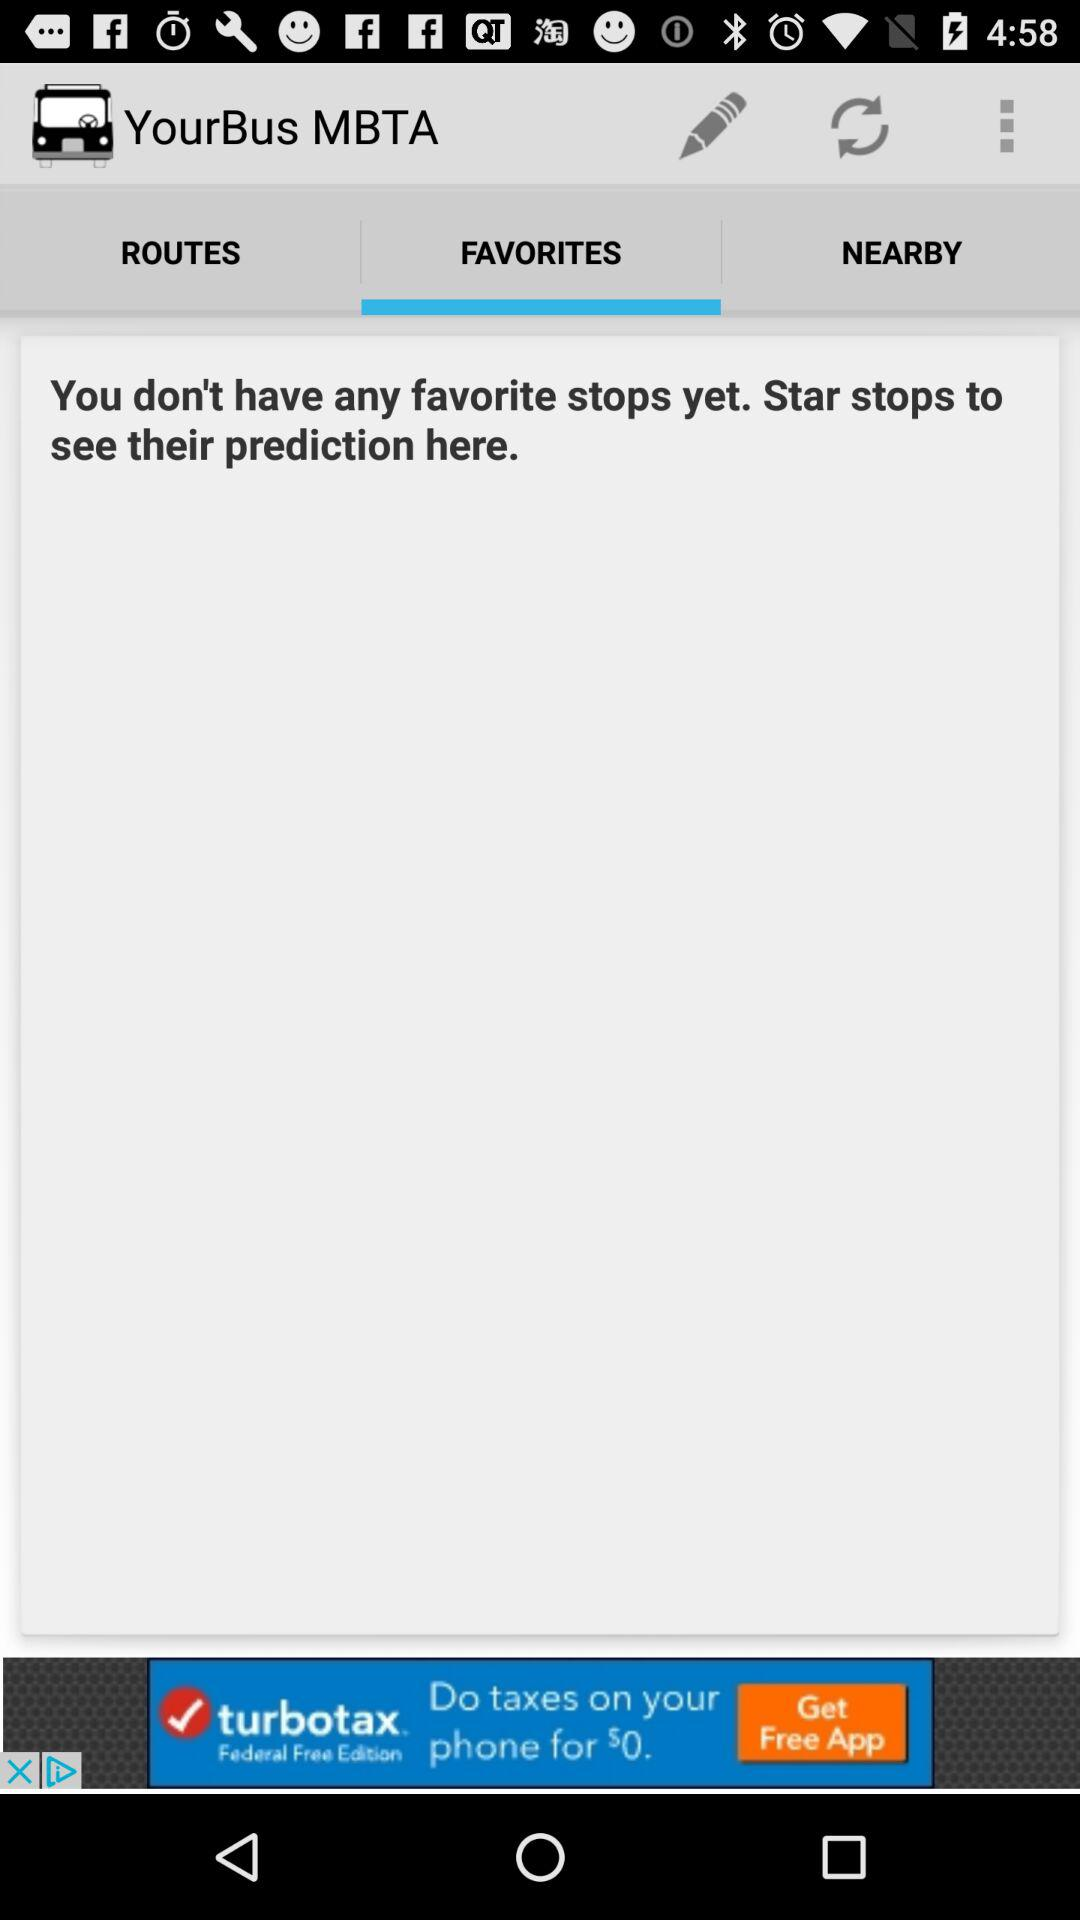What is the application name? The application name is "YourBus MBTA". 